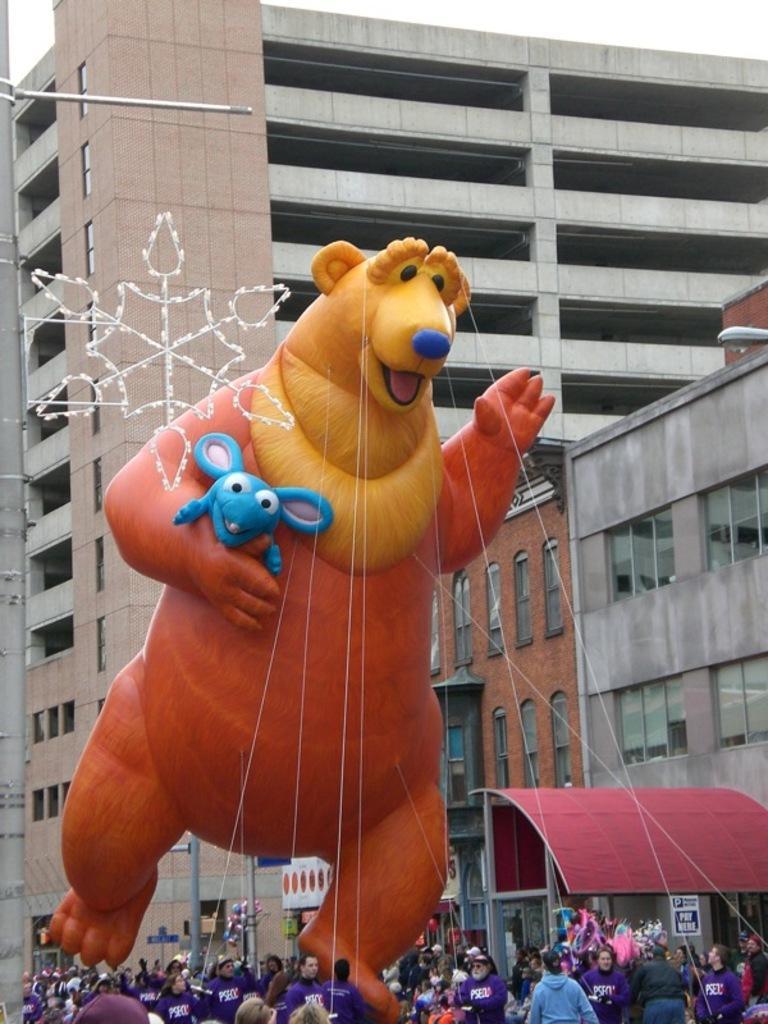Can you describe this image briefly? In this image there are a few people holding a gas balloon of an animal structure with ropes, behind them there are buildings and lamp posts. 